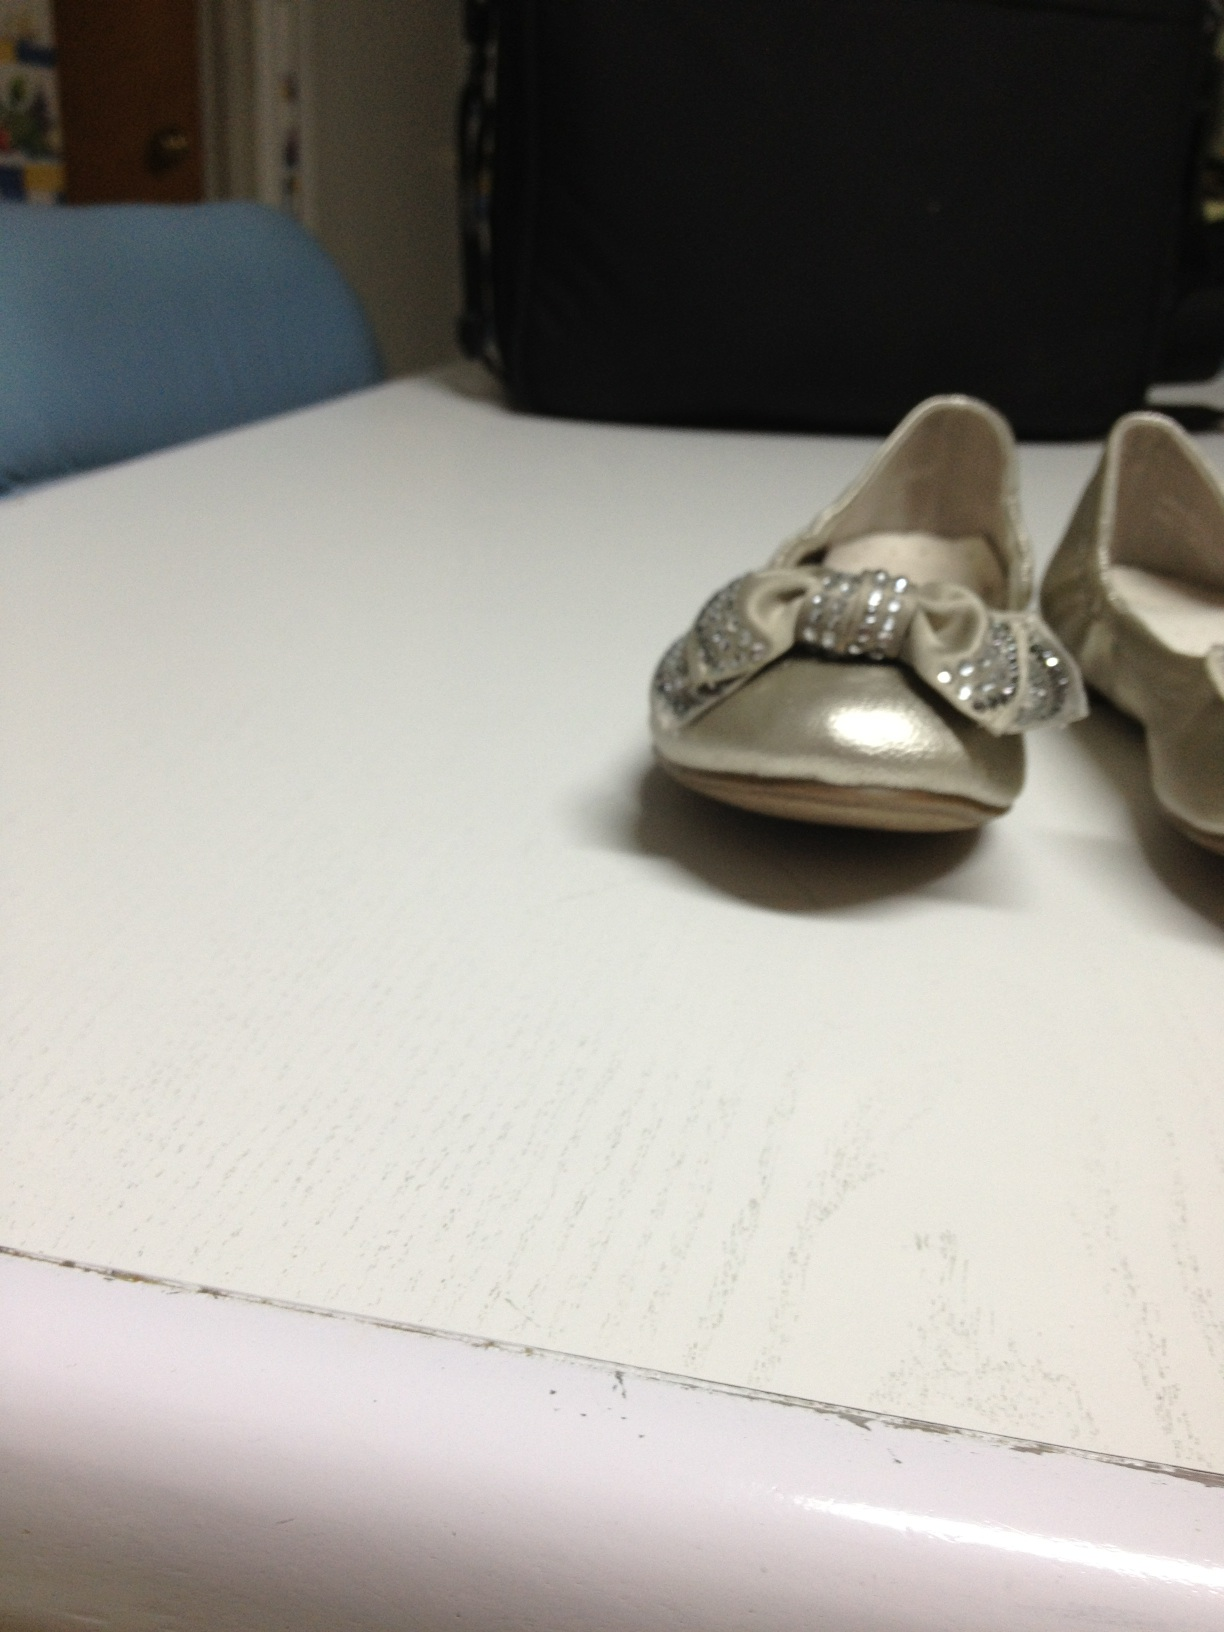Imagine these shoes belonged to a princess. Describe her story. Once upon a time, in a faraway kingdom, there lived a young princess named Isabella. She was known throughout the land for her kindness and grace. On her fifth birthday, Queen Amelia gifted her a pair of exquisite silver shoes adorned with shimmering bows. These shoes were said to have been crafted by the finest artisans in the kingdom, enchanted to bring luck and joy to the wearer. Princess Isabella cherished these shoes and wore them on every important occasion, from grand balls in the royal palace to secret wanderings in the enchanted forest nearby. 